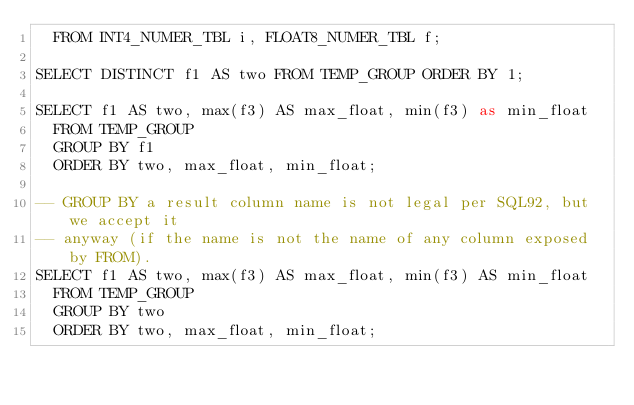<code> <loc_0><loc_0><loc_500><loc_500><_SQL_>  FROM INT4_NUMER_TBL i, FLOAT8_NUMER_TBL f;

SELECT DISTINCT f1 AS two FROM TEMP_GROUP ORDER BY 1;

SELECT f1 AS two, max(f3) AS max_float, min(f3) as min_float
  FROM TEMP_GROUP
  GROUP BY f1
  ORDER BY two, max_float, min_float;

-- GROUP BY a result column name is not legal per SQL92, but we accept it
-- anyway (if the name is not the name of any column exposed by FROM).
SELECT f1 AS two, max(f3) AS max_float, min(f3) AS min_float
  FROM TEMP_GROUP
  GROUP BY two
  ORDER BY two, max_float, min_float;
</code> 